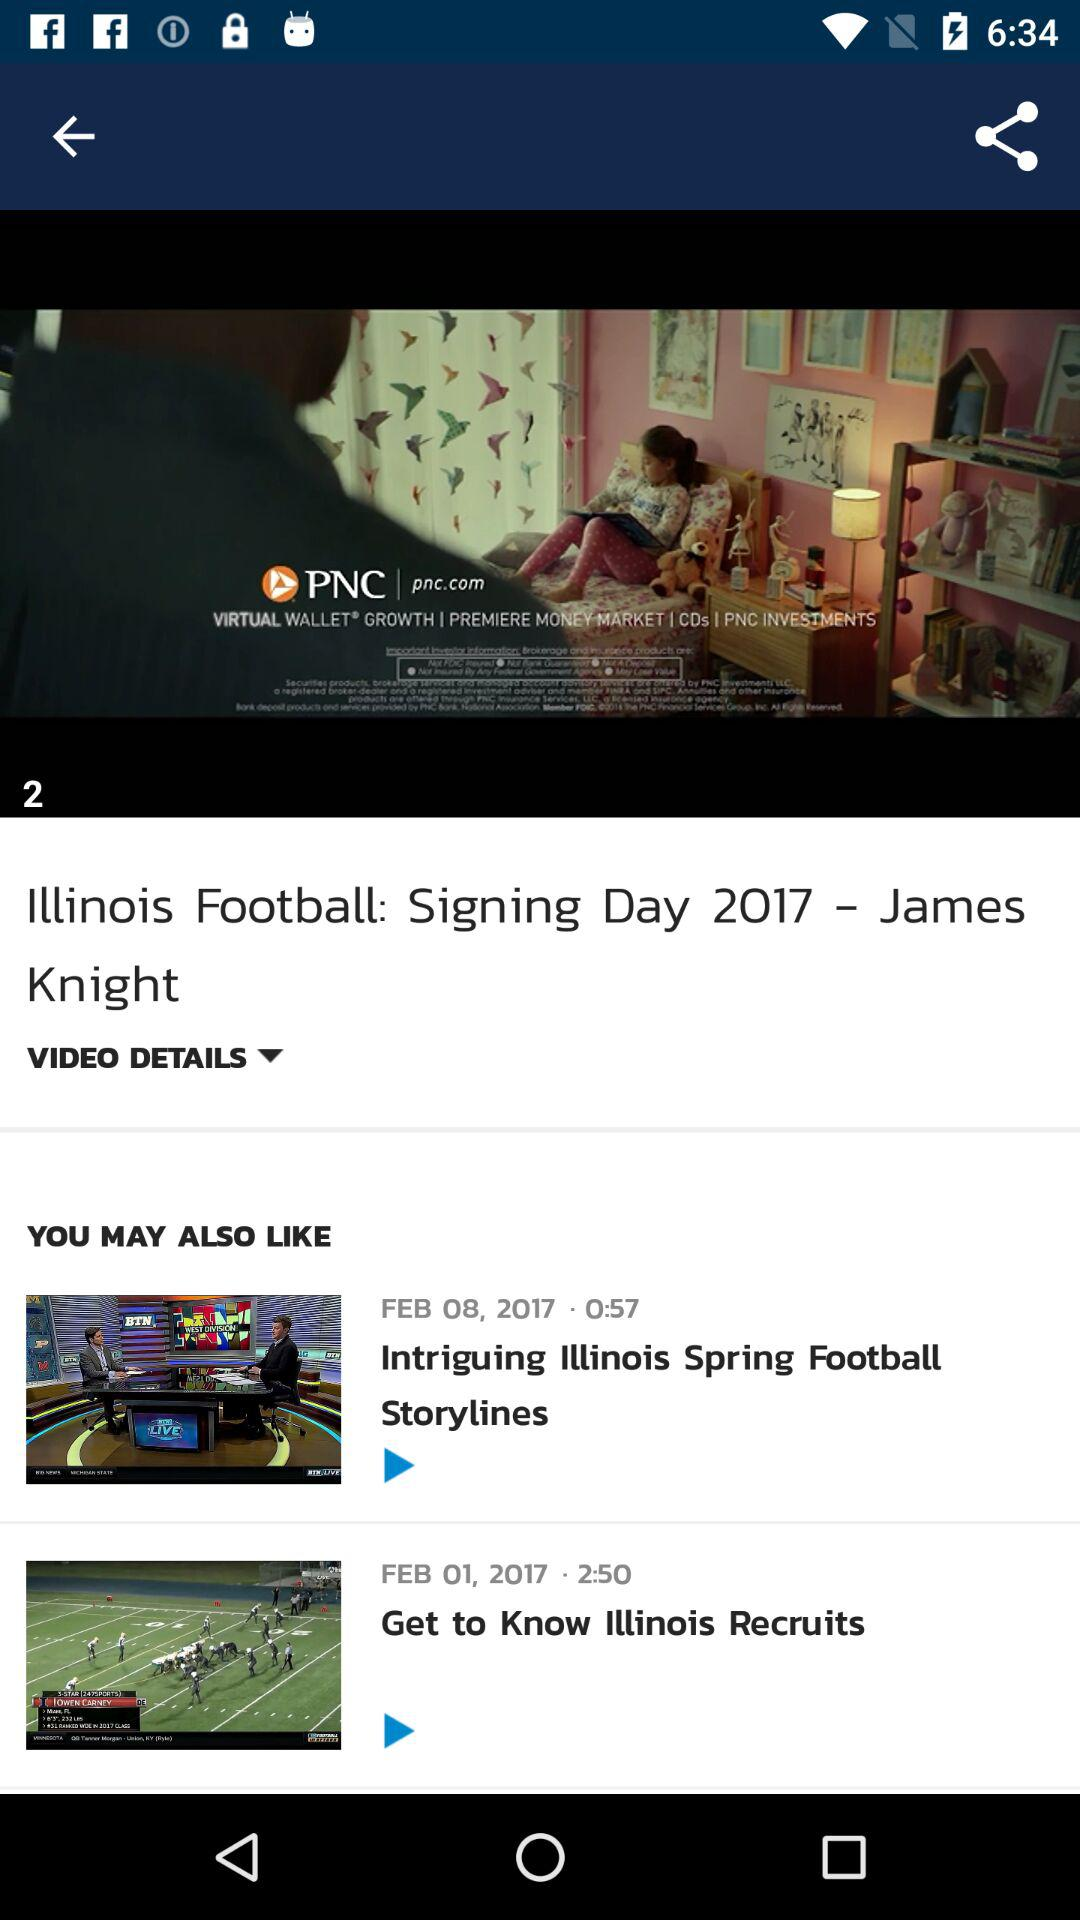What is the duration of the video "Intriguing Illinois Spring Football Storylines"? The duration is 57 seconds. 